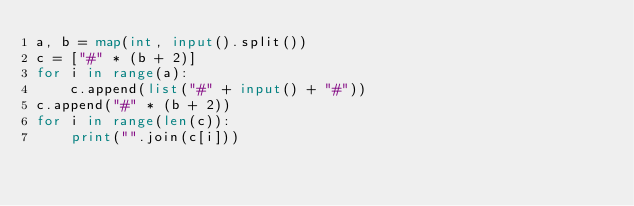<code> <loc_0><loc_0><loc_500><loc_500><_Python_>a, b = map(int, input().split())
c = ["#" * (b + 2)]
for i in range(a):
    c.append(list("#" + input() + "#"))
c.append("#" * (b + 2))
for i in range(len(c)):
    print("".join(c[i]))
</code> 